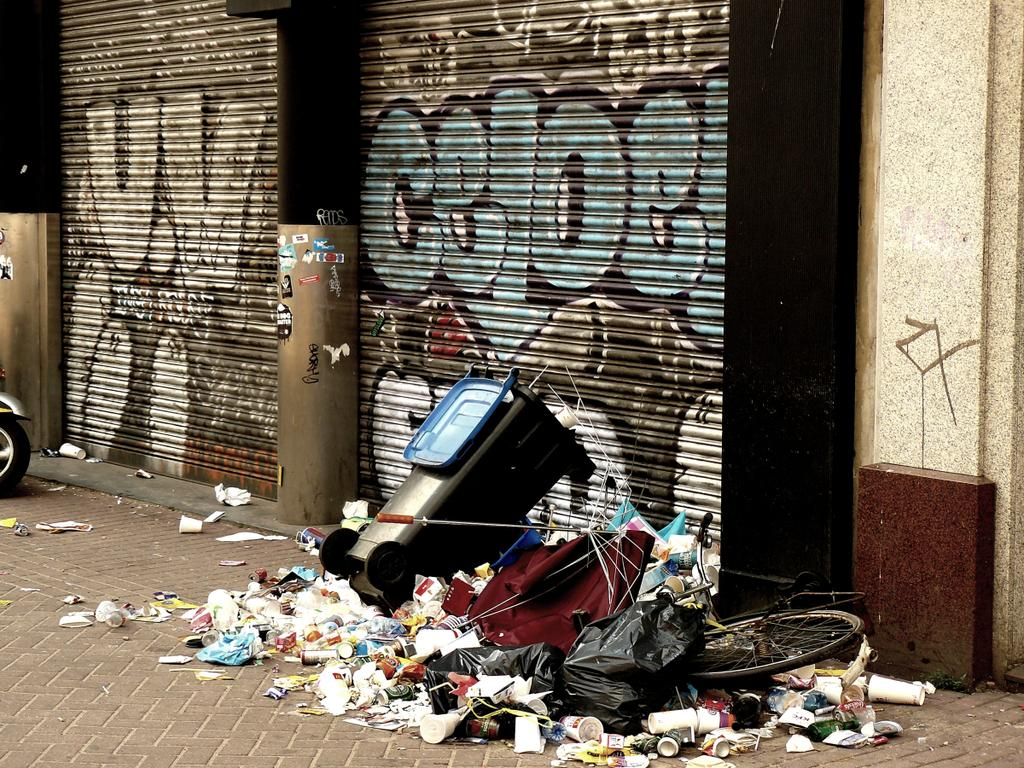<image>
Present a compact description of the photo's key features. A heap of trash and a trash can with a graffiti saying celoe at the back. 